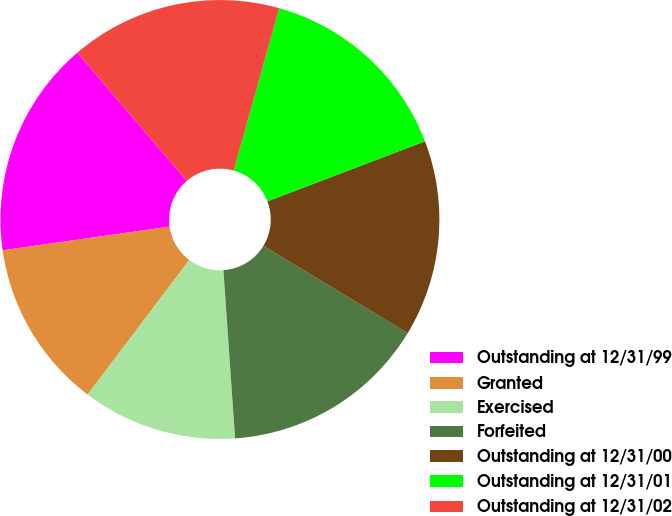Convert chart to OTSL. <chart><loc_0><loc_0><loc_500><loc_500><pie_chart><fcel>Outstanding at 12/31/99<fcel>Granted<fcel>Exercised<fcel>Forfeited<fcel>Outstanding at 12/31/00<fcel>Outstanding at 12/31/01<fcel>Outstanding at 12/31/02<nl><fcel>15.99%<fcel>12.46%<fcel>11.4%<fcel>15.23%<fcel>14.47%<fcel>14.85%<fcel>15.61%<nl></chart> 